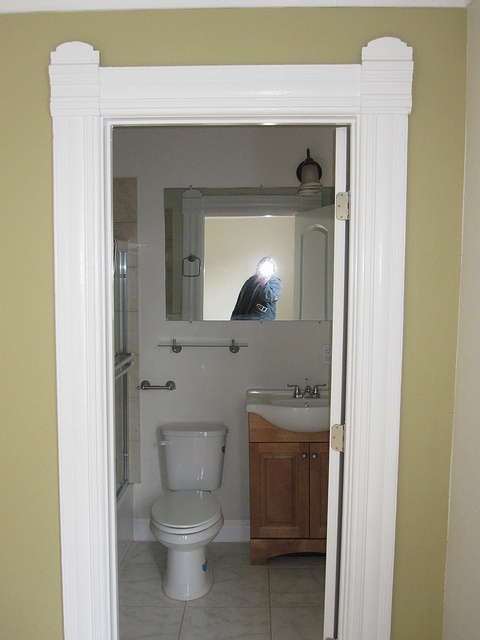Describe the objects in this image and their specific colors. I can see toilet in lightgray and gray tones, sink in lightgray, gray, and black tones, and people in lightgray, black, gray, and darkgray tones in this image. 